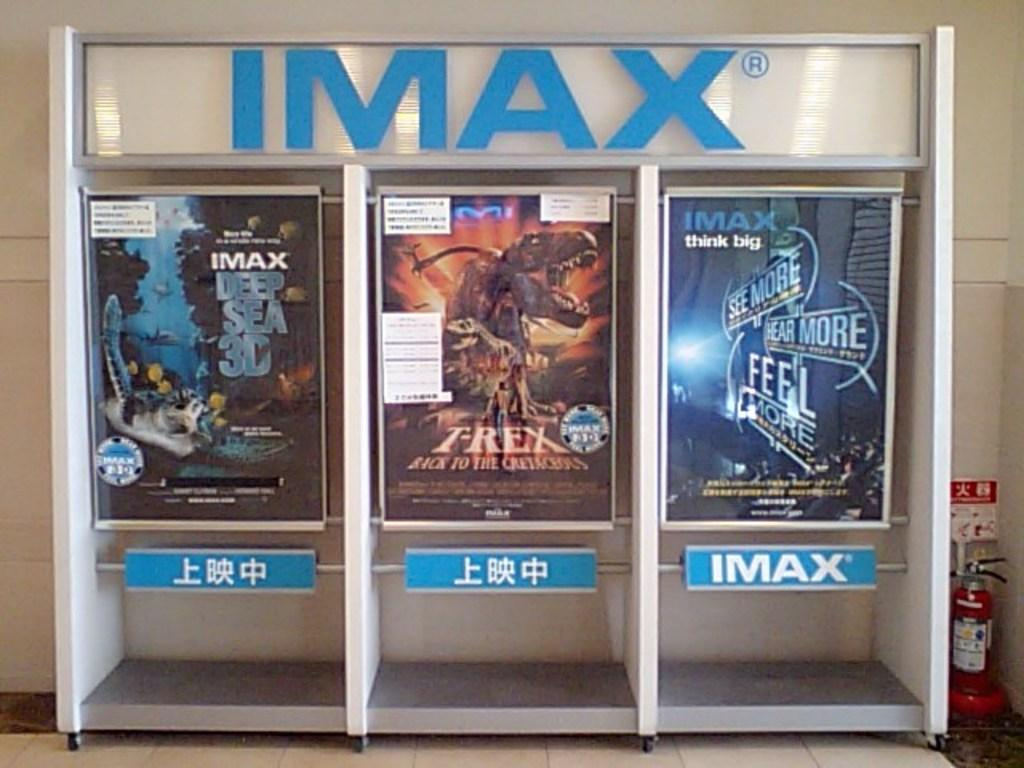<image>
Write a terse but informative summary of the picture. some movie advertisements for Trex and other films 